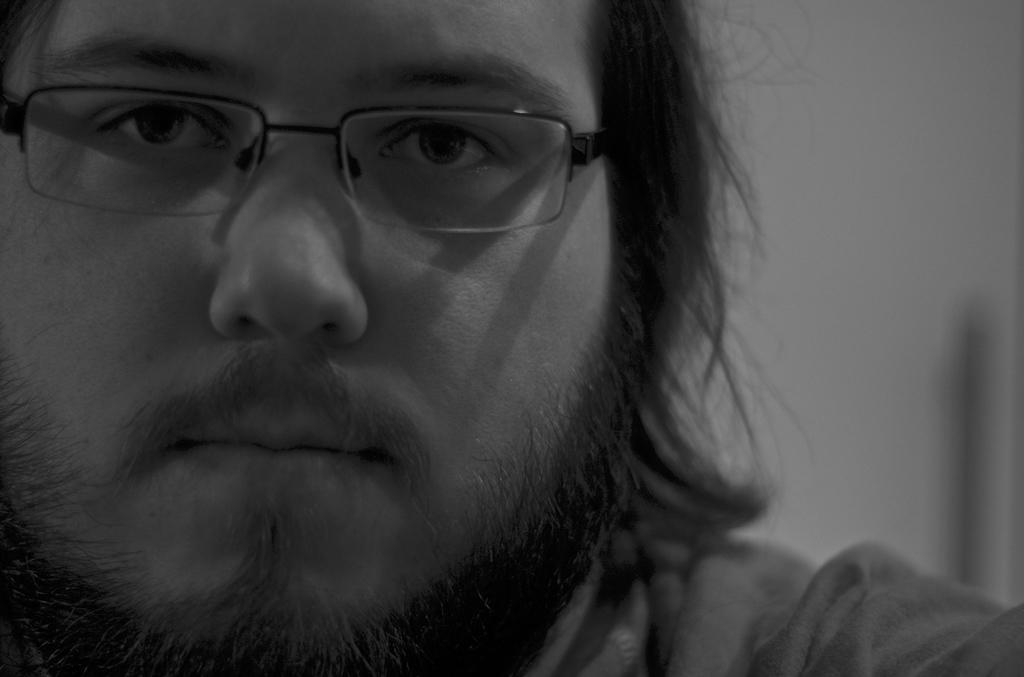What is the main subject of the image? The main subject of the image is a man's face. What can be seen on the man's face in the image? The man is wearing spectacles in the image. What is the color scheme of the image? The image is black and white. What type of sail can be seen in the image? There is no sail present in the image; it features a man's face with spectacles. How many shades of gray are visible in the image? The question cannot be answered definitively, as the number of shades of gray in a black and white image can vary depending on the image's quality and the viewer's perception. 